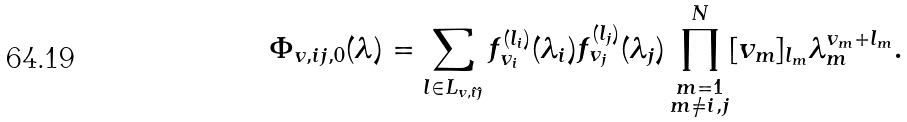Convert formula to latex. <formula><loc_0><loc_0><loc_500><loc_500>\Phi _ { v , i j , { 0 } } ( \lambda ) = \sum _ { l \in L _ { v , \hat { \imath } \hat { \jmath } } } f _ { v _ { i } } ^ { ( l _ { i } ) } ( \lambda _ { i } ) f _ { v _ { j } } ^ { ( l _ { j } ) } ( \lambda _ { j } ) \prod _ { \substack { m = 1 \\ m \neq i , j } } ^ { N } [ v _ { m } ] _ { l _ { m } } \lambda _ { m } ^ { v _ { m } + l _ { m } } .</formula> 